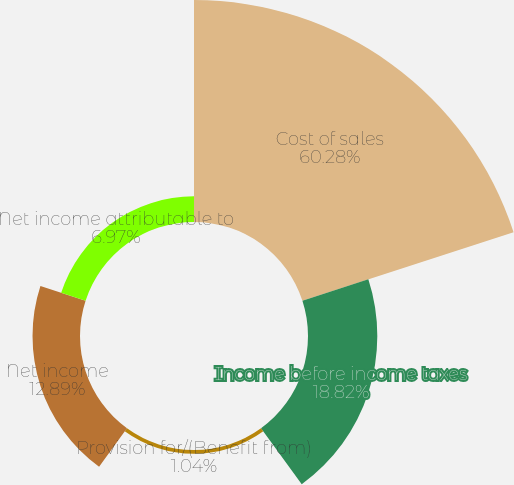Convert chart to OTSL. <chart><loc_0><loc_0><loc_500><loc_500><pie_chart><fcel>Cost of sales<fcel>Income before income taxes<fcel>Provision for/(Benefit from)<fcel>Net income<fcel>Net income attributable to<nl><fcel>60.28%<fcel>18.82%<fcel>1.04%<fcel>12.89%<fcel>6.97%<nl></chart> 